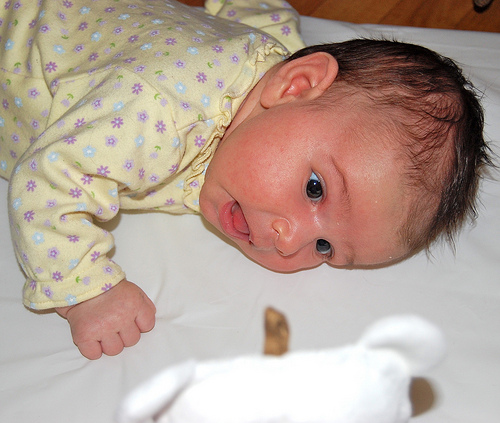<image>
Can you confirm if the baby is on the teddy bear? No. The baby is not positioned on the teddy bear. They may be near each other, but the baby is not supported by or resting on top of the teddy bear. 